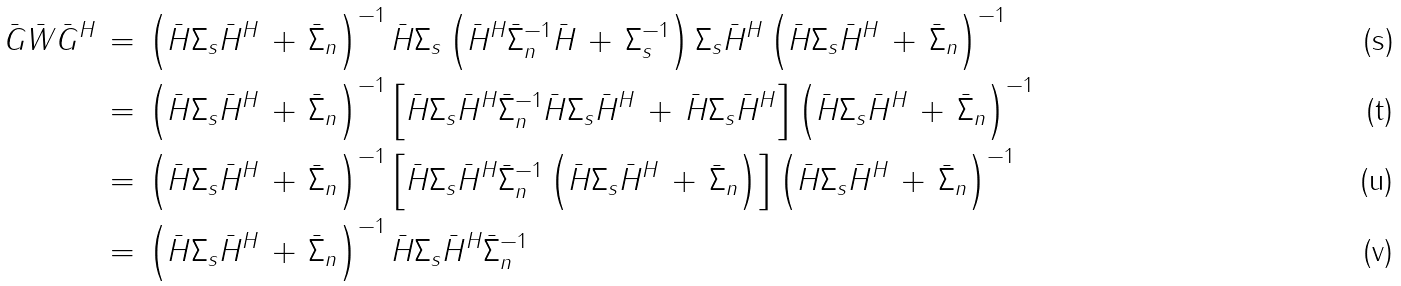Convert formula to latex. <formula><loc_0><loc_0><loc_500><loc_500>\bar { G } \bar { W } \bar { G } ^ { H } & \, = \, \left ( \bar { H } \Sigma _ { s } \bar { H } ^ { H } \, + \, \bar { \Sigma } _ { n } \right ) ^ { - 1 } \bar { H } \Sigma _ { s } \left ( \bar { H } ^ { H } \bar { \Sigma } _ { n } ^ { - 1 } \bar { H } \, + \, \Sigma _ { s } ^ { - 1 } \right ) \Sigma _ { s } \bar { H } ^ { H } \left ( \bar { H } \Sigma _ { s } \bar { H } ^ { H } \, + \, \bar { \Sigma } _ { n } \right ) ^ { - 1 } \\ & \, = \, \left ( \bar { H } \Sigma _ { s } \bar { H } ^ { H } \, + \, \bar { \Sigma } _ { n } \right ) ^ { - 1 } \left [ \bar { H } \Sigma _ { s } \bar { H } ^ { H } \bar { \Sigma } _ { n } ^ { - 1 } \bar { H } \Sigma _ { s } \bar { H } ^ { H } \, + \, \bar { H } \Sigma _ { s } \bar { H } ^ { H } \right ] \left ( \bar { H } \Sigma _ { s } \bar { H } ^ { H } \, + \, \bar { \Sigma } _ { n } \right ) ^ { - 1 } \\ & \, = \, \left ( \bar { H } \Sigma _ { s } \bar { H } ^ { H } \, + \, \bar { \Sigma } _ { n } \right ) ^ { - 1 } \left [ \bar { H } \Sigma _ { s } \bar { H } ^ { H } \bar { \Sigma } _ { n } ^ { - 1 } \left ( \bar { H } \Sigma _ { s } \bar { H } ^ { H } \, + \, \bar { \Sigma } _ { n } \right ) \right ] \left ( \bar { H } \Sigma _ { s } \bar { H } ^ { H } \, + \, \bar { \Sigma } _ { n } \right ) ^ { - 1 } \\ & \, = \, \left ( \bar { H } \Sigma _ { s } \bar { H } ^ { H } \, + \, \bar { \Sigma } _ { n } \right ) ^ { - 1 } \bar { H } \Sigma _ { s } \bar { H } ^ { H } \bar { \Sigma } _ { n } ^ { - 1 }</formula> 